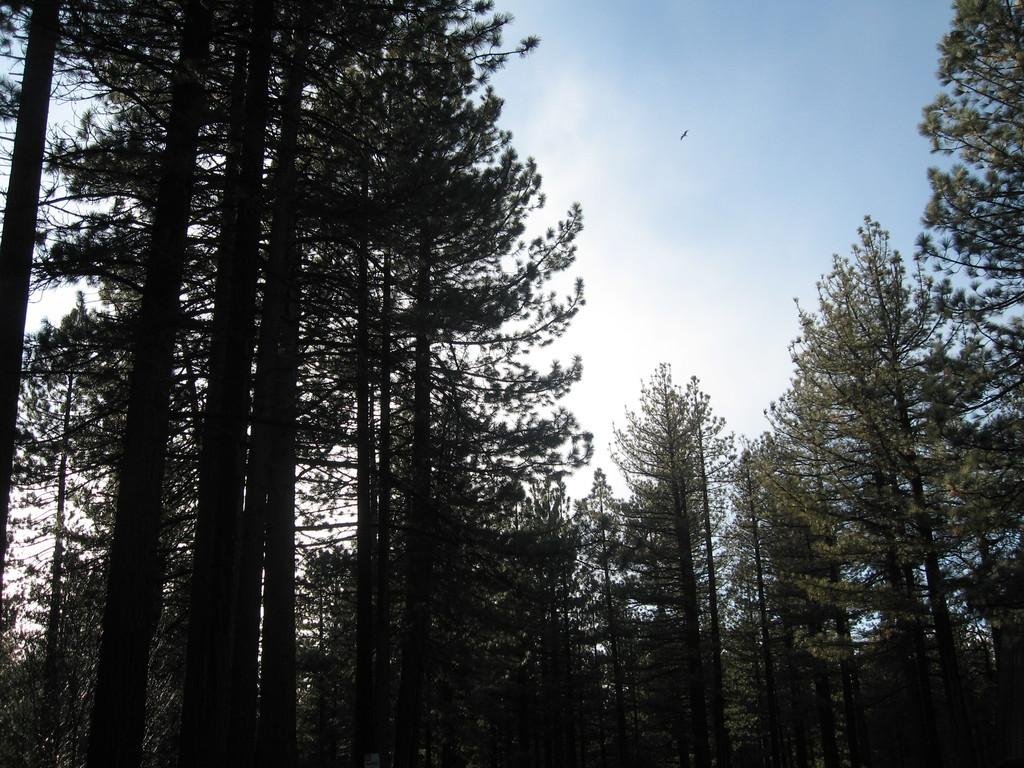What type of vegetation can be seen in the image? There are trees in the image. What is happening in the background of the image? There is a bird flying in the air in the background of the image. What part of the natural environment is visible in the image? The sky is visible in the background of the image. What type of leather is being used to make the food in the image? There is no leather or food present in the image; it features trees and a bird flying in the sky. 